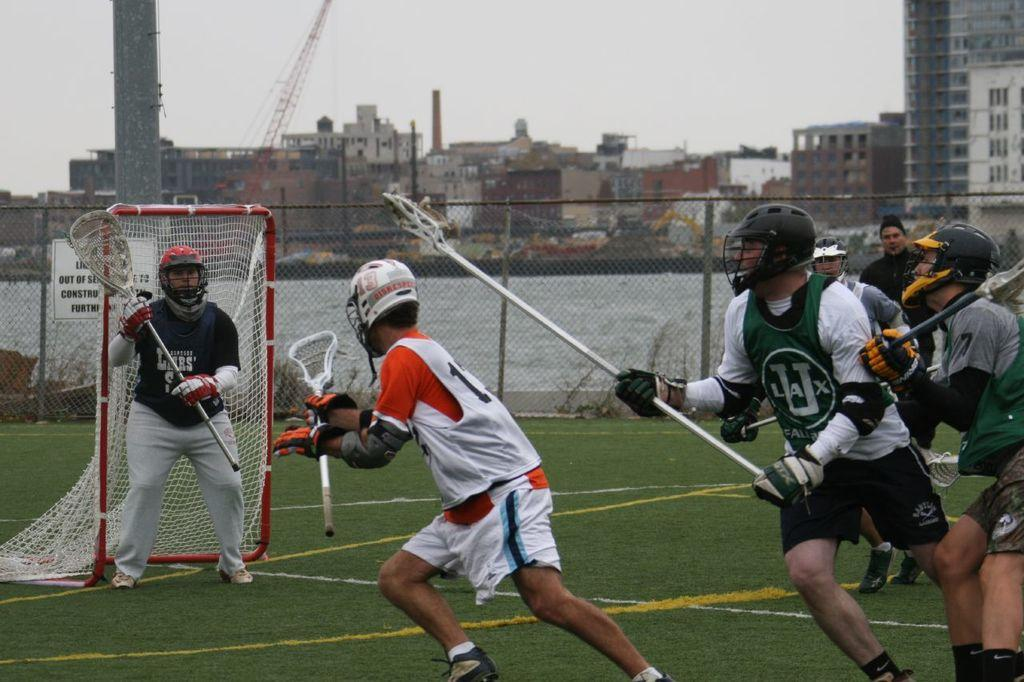<image>
Provide a brief description of the given image. A game of lacrosse is in progress and one of the two teams wears green U LAX team shirts. 